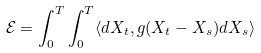Convert formula to latex. <formula><loc_0><loc_0><loc_500><loc_500>\mathcal { E } = \int _ { 0 } ^ { T } \int _ { 0 } ^ { T } \langle d X _ { t } , g ( X _ { t } - X _ { s } ) d X _ { s } \rangle</formula> 